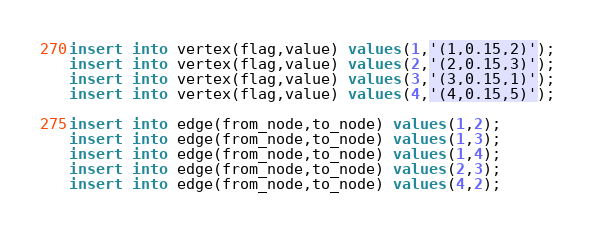<code> <loc_0><loc_0><loc_500><loc_500><_SQL_>insert into vertex(flag,value) values(1,'(1,0.15,2)');
insert into vertex(flag,value) values(2,'(2,0.15,3)');
insert into vertex(flag,value) values(3,'(3,0.15,1)');
insert into vertex(flag,value) values(4,'(4,0.15,5)');

insert into edge(from_node,to_node) values(1,2);
insert into edge(from_node,to_node) values(1,3);
insert into edge(from_node,to_node) values(1,4);
insert into edge(from_node,to_node) values(2,3);
insert into edge(from_node,to_node) values(4,2);
</code> 